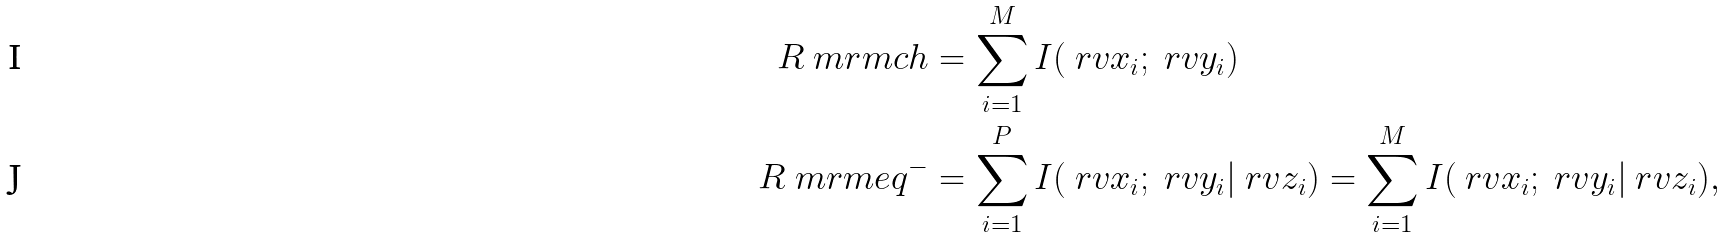<formula> <loc_0><loc_0><loc_500><loc_500>R _ { \ } m r m { c h } & = \sum _ { i = 1 } ^ { M } I ( \ r v x _ { i } ; \ r v y _ { i } ) \\ R _ { \ } m r m { e q } ^ { - } & = \sum _ { i = 1 } ^ { P } I ( \ r v x _ { i } ; \ r v y _ { i } | \ r v z _ { i } ) = \sum _ { i = 1 } ^ { M } I ( \ r v x _ { i } ; \ r v y _ { i } | \ r v z _ { i } ) ,</formula> 